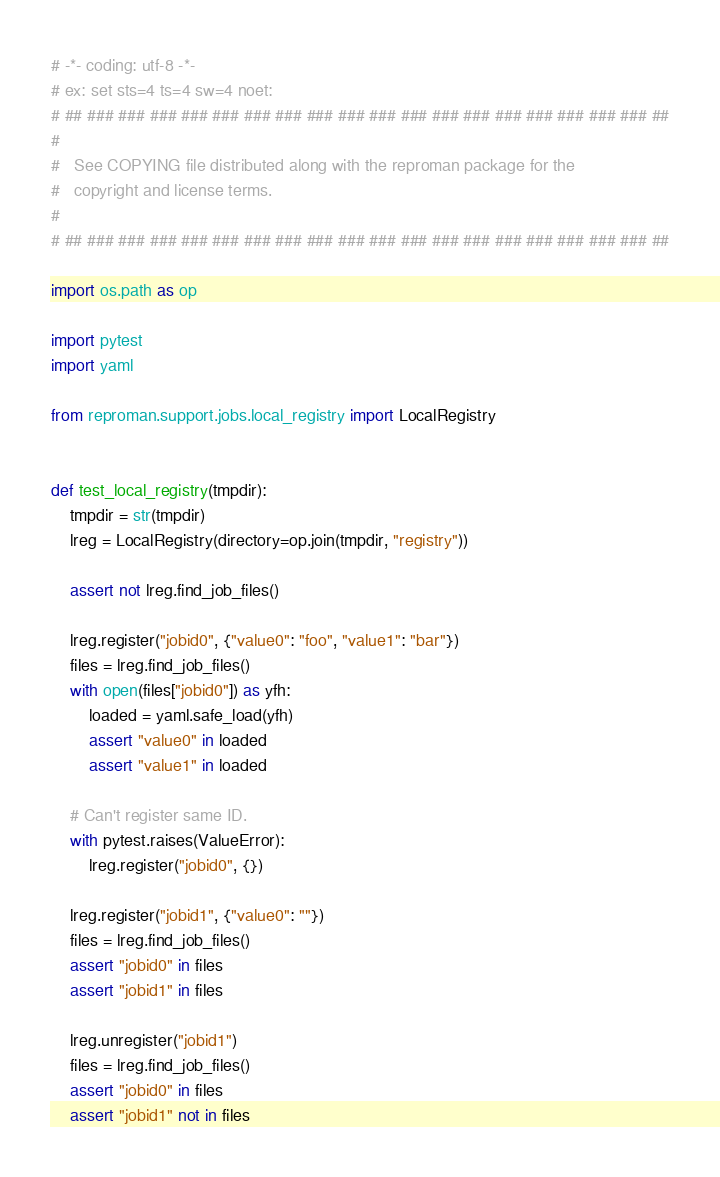<code> <loc_0><loc_0><loc_500><loc_500><_Python_># -*- coding: utf-8 -*-
# ex: set sts=4 ts=4 sw=4 noet:
# ## ### ### ### ### ### ### ### ### ### ### ### ### ### ### ### ### ### ### ##
#
#   See COPYING file distributed along with the reproman package for the
#   copyright and license terms.
#
# ## ### ### ### ### ### ### ### ### ### ### ### ### ### ### ### ### ### ### ##

import os.path as op

import pytest
import yaml

from reproman.support.jobs.local_registry import LocalRegistry


def test_local_registry(tmpdir):
    tmpdir = str(tmpdir)
    lreg = LocalRegistry(directory=op.join(tmpdir, "registry"))

    assert not lreg.find_job_files()

    lreg.register("jobid0", {"value0": "foo", "value1": "bar"})
    files = lreg.find_job_files()
    with open(files["jobid0"]) as yfh:
        loaded = yaml.safe_load(yfh)
        assert "value0" in loaded
        assert "value1" in loaded

    # Can't register same ID.
    with pytest.raises(ValueError):
        lreg.register("jobid0", {})

    lreg.register("jobid1", {"value0": ""})
    files = lreg.find_job_files()
    assert "jobid0" in files
    assert "jobid1" in files

    lreg.unregister("jobid1")
    files = lreg.find_job_files()
    assert "jobid0" in files
    assert "jobid1" not in files
</code> 